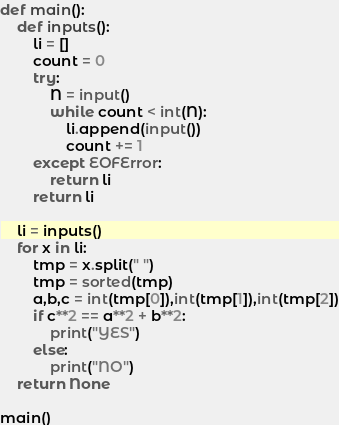<code> <loc_0><loc_0><loc_500><loc_500><_Python_>def main():
    def inputs():
        li = []
        count = 0
        try:
            N = input()
            while count < int(N):
                li.append(input())
                count += 1
        except EOFError:
            return li
        return li

    li = inputs()
    for x in li:
        tmp = x.split(" ")
        tmp = sorted(tmp)
        a,b,c = int(tmp[0]),int(tmp[1]),int(tmp[2])
        if c**2 == a**2 + b**2:
            print("YES")
        else:
            print("NO")
    return None

main()</code> 